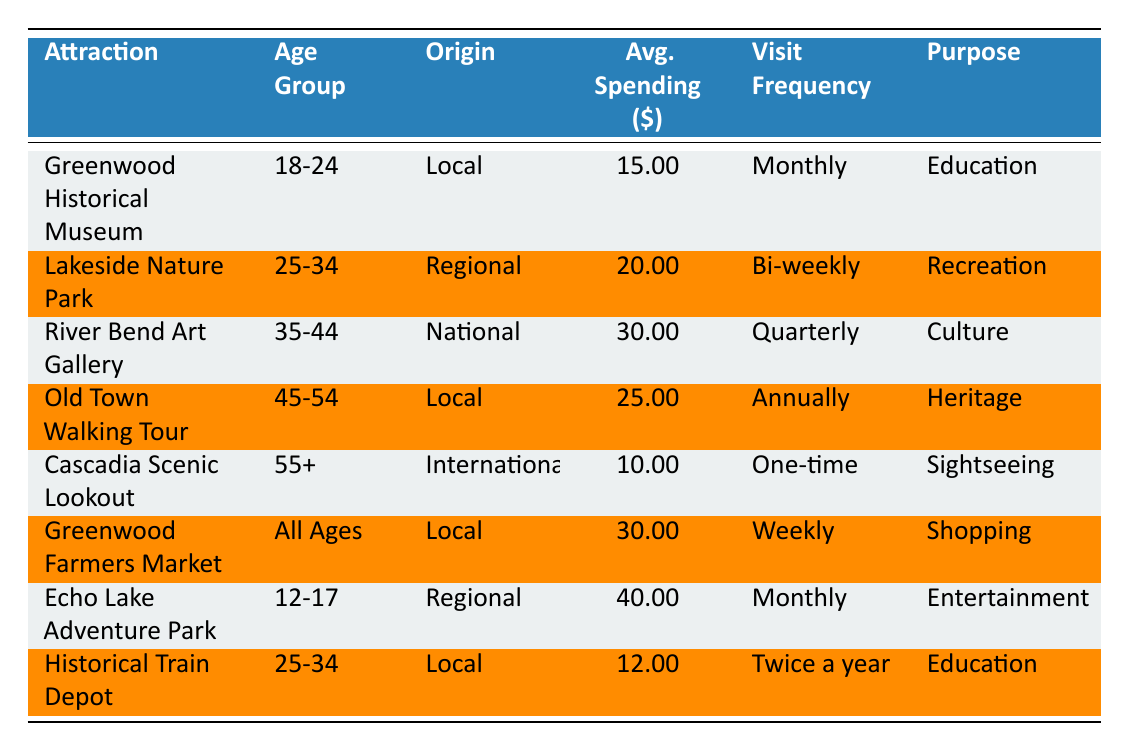What is the average spending of visitors at the Greenwood Historical Museum? The average spending for the Greenwood Historical Museum, according to the table, is directly listed. It shows the value as 15.00.
Answer: 15.00 Which attraction has the highest average spending by visitors? From the table, the highest average spending is found at the Echo Lake Adventure Park, which shows an average spending of 40.00.
Answer: 40.00 How many attractions have a visitor origin listed as "Local"? By counting the rows in the table, there are four attractions with the visitor origin labeled as "Local": Greenwood Historical Museum, Old Town Walking Tour, Greenwood Farmers Market, and Historical Train Depot.
Answer: 4 Is the average spending of visitors at the Lakeside Nature Park greater than that at Echo Lake Adventure Park? The average spending at Lakeside Nature Park is listed as 20.00, while Echo Lake Adventure Park is at 40.00. Since 20.00 is less than 40.00, the statement is false.
Answer: No What is the total average spending of visitors from the age group 25-34 across all attractions? There are two attractions in this age group: Lakeside Nature Park with an average spending of 20.00, and Historical Train Depot with 12.00. The total average spending is calculated by adding these two values: 20.00 + 12.00 = 32.00.
Answer: 32.00 Which age group visits the Greenwood Farmers Market? The Greenwood Farmers Market is listed under the "All Ages" category regarding the visitor age group. This indicates that all age groups can visit this attraction.
Answer: All Ages Do visitors from the 55+ age group spend more on average than the 18-24 age group? The table shows an average spending of 10.00 for the 55+ age group from the Cascadia Scenic Lookout, and 15.00 for the 18-24 age group at the Greenwood Historical Museum. Since 10.00 is less than 15.00, the statement is false.
Answer: No What is the frequency of visits for the River Bend Art Gallery? The table specifies that the River Bend Art Gallery has a visit frequency listed as Quarterly. This means visitors typically visit the attraction every three months.
Answer: Quarterly How does the spending at the Old Town Walking Tour compare to the spending at the Greenwood Historical Museum? Old Town Walking Tour shows an average spending of 25.00, while the Greenwood Historical Museum averages 15.00. 25.00 is greater than 15.00, indicating that visitors spend more at Old Town Walking Tour.
Answer: Yes 